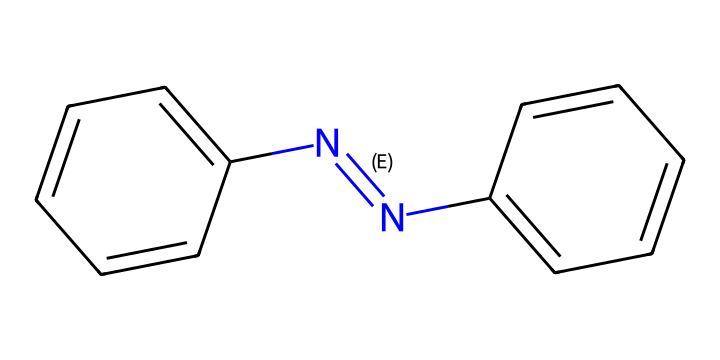What is the total number of carbon atoms in azobenzene? The SMILES representation shows two benzene rings, each containing six carbon atoms. Thus, the total number of carbon atoms is six from the first ring and six from the second ring, resulting in a total of twelve carbon atoms.
Answer: twelve How many nitrogen atoms are in the azobenzene structure? The SMILES representation includes a N=N bond, indicating the presence of two nitrogen atoms between the two benzene rings. Therefore, there are two nitrogen atoms.
Answer: two What is the E-Z configuration of this azobenzene isomer? The given structure indicates that the two phenyl groups are on opposite sides of the N=N bond, which is characteristic of the E configuration for geometric isomers.
Answer: E What type of isomerism is present in azobenzene? Azobenzene exhibits geometric isomerism due to the restricted rotation around the N=N bond, leading to distinct arrangements based on the spatial positioning of the substituents.
Answer: geometric isomerism In drug delivery systems, why is the E-Z configuration significant? The E-Z configuration influences the solubility, absorption, and interaction of the drug compound within biological systems, which can affect its efficacy and targeted delivery.
Answer: solubility and interaction What bond type connects the nitrogen atoms in azobenzene? The connection between the nitrogen atoms is through a double bond, specifically a nitrogen-nitrogen double bond (N=N), which is a defining feature of azobenzene.
Answer: double bond How does the presence of the N=N bond affect the reactivity of azobenzene? The N=N bond introduces a point of reactivity in azobenzene, making it susceptible to reduction or photoisomerization, particularly under UV light, which can influence its utility in drug delivery systems.
Answer: reactivity 